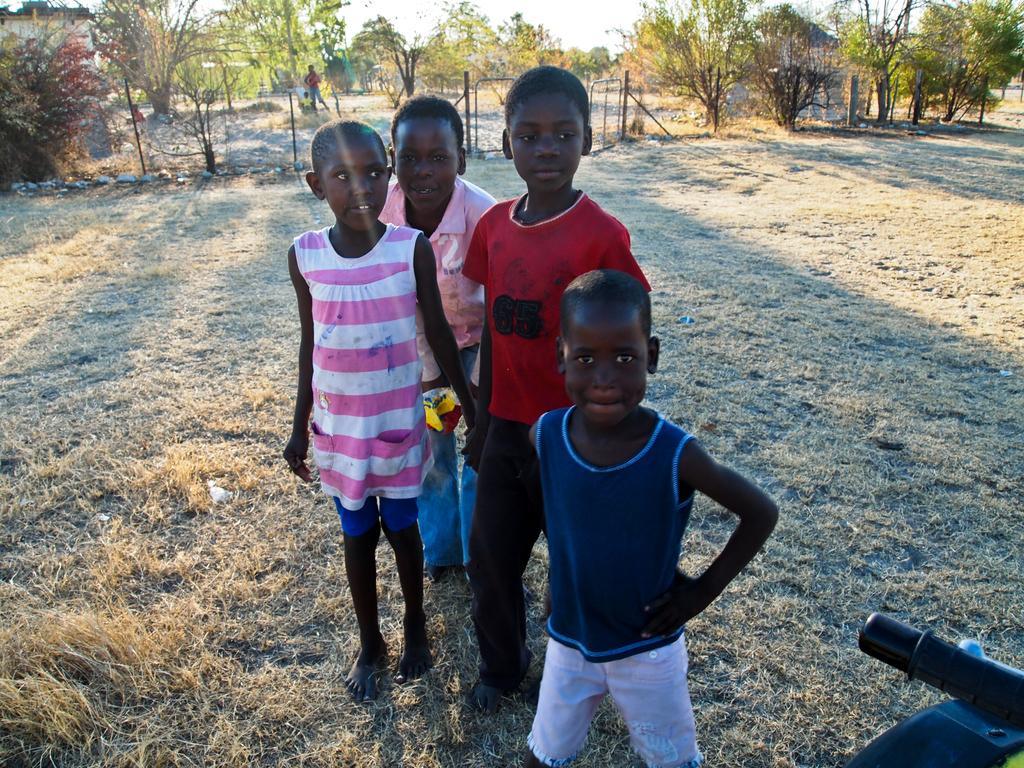Can you describe this image briefly? In this image we can see a few children are standing. There are many trees at the top most of the image. There is an object at the bottom right most of the image. There is a grassy land in the image. 